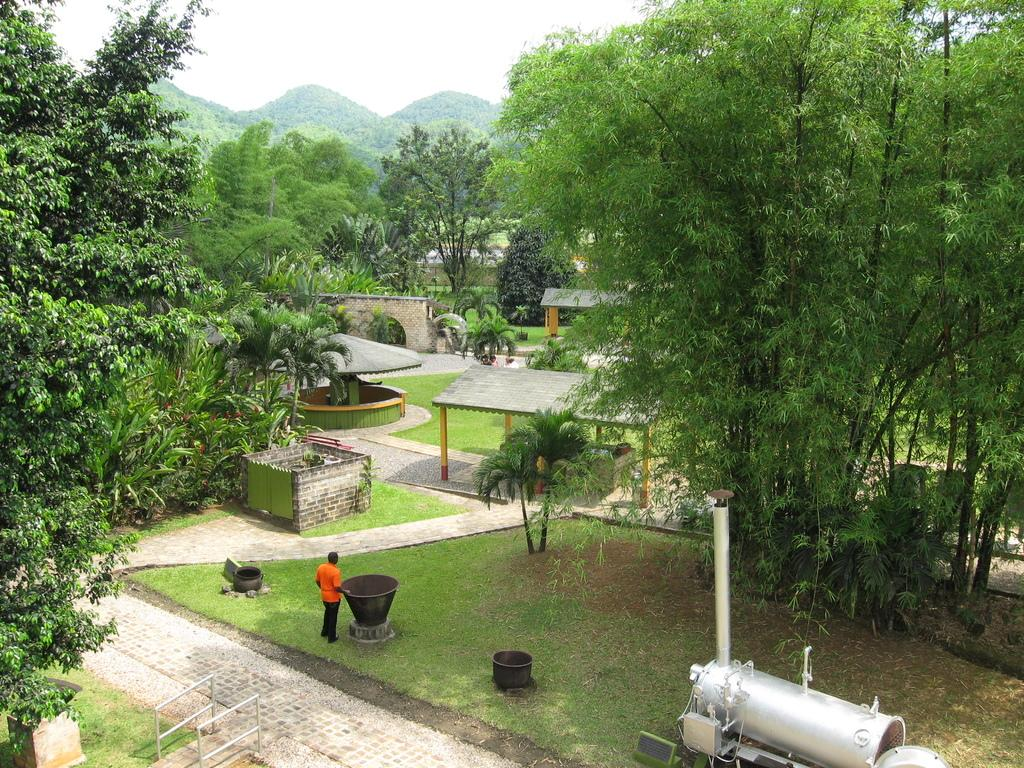What is the person in the image standing next to? The person is standing next to a tub in the image. What type of temporary shelters can be seen in the image? There are tents visible in the image. What type of vegetation is present in the image? Trees and grass are present in the image. What type of landscape feature can be seen in the image? There are hills in the image. What type of equipment is visible in the image? A machine is visible in the image. How many cows are tied up in a knot in the image? There are no cows or knots present in the image. What type of advice does the mother give to the person in the image? There is no mother or advice-giving in the image. 